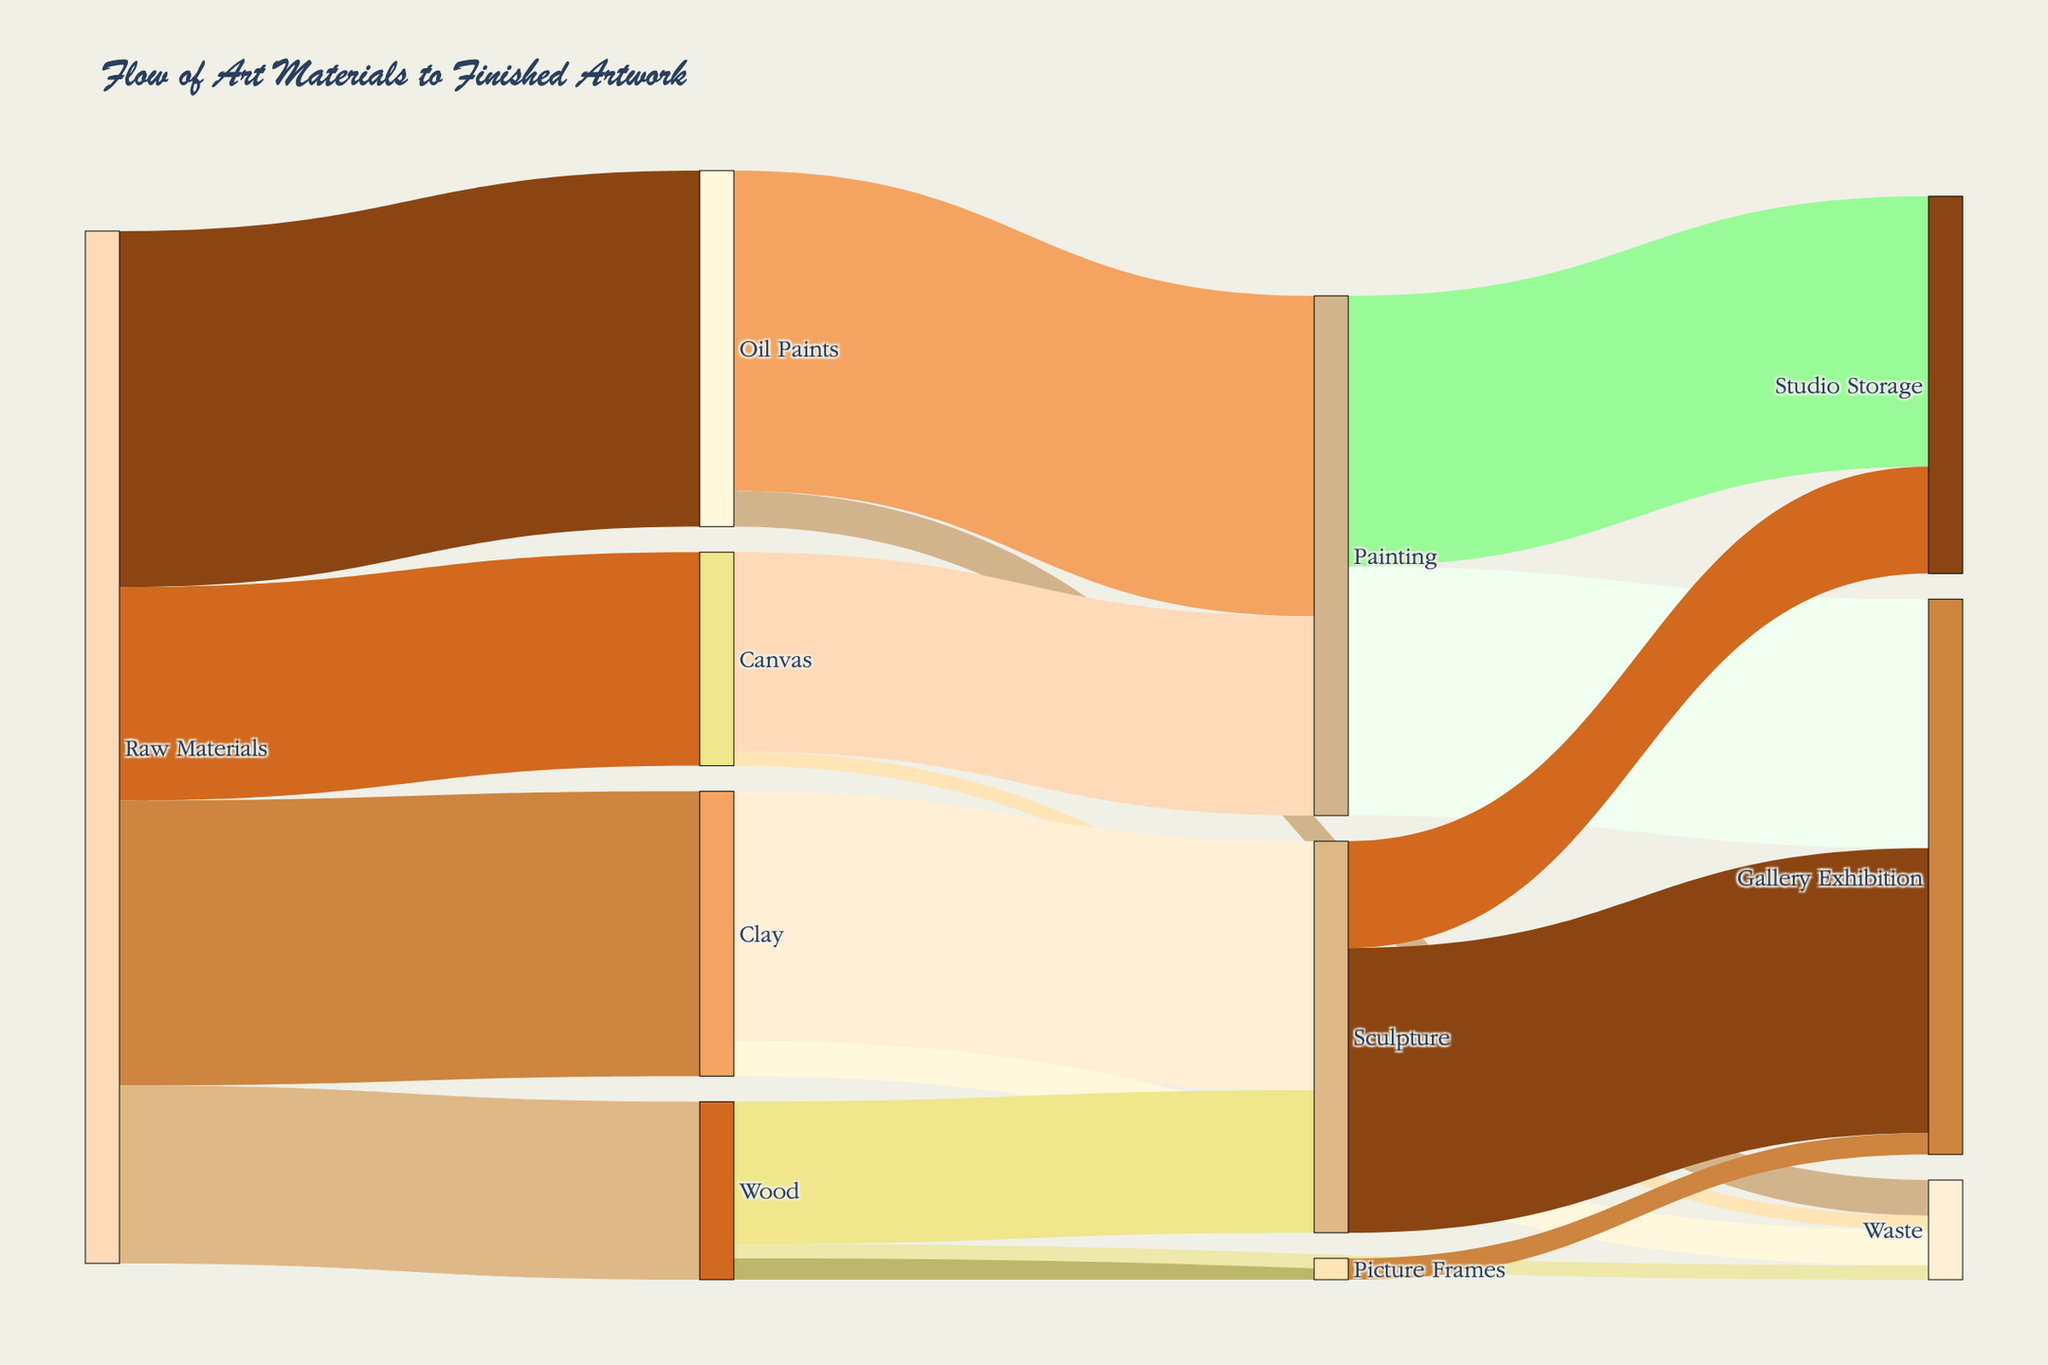What is the title of the figure? The title is located at the top of the Sankey diagram and usually provides the main context of the visualization. Here, it indicates what the diagram is about.
Answer: Flow of Art Materials to Finished Artwork How many types of raw materials are used? By counting the distinct 'source' nodes connected to 'Raw Materials', we can determine the variety of raw materials.
Answer: 4 Which raw material has the highest amount used in creating finished art pieces? By looking at the flow values from 'Raw Materials' to their respective targets, we can identify the material with the highest value.
Answer: Oil Paints (50 units) How much waste is generated from canvas? We find the 'Canvas' node and check the flow directed towards 'Waste' to know the exact amount of waste generated.
Answer: 2 units What is the total amount of material directed towards gallery exhibitions? Summing up the flow values directed to 'Gallery Exhibition' from 'Painting', 'Sculpture', and 'Picture Frames'. This involves adding 35 + 40 + 3.
Answer: 78 units Which finished art form has more waste: Painting or Sculpture? By comparing the waste flows from 'Painting' and 'Sculpture', we can see where more material is wasted.
Answer: Painting (5 units for Painting, 5 units for Sculpture) What is the difference between the amount of clay used in sculptures and the amount of wood used in sculptures? Subtract the flow value of 'Wood' to 'Sculpture' from the flow value of 'Clay' to 'Sculpture' to find the difference.
Answer: 15 units (35 - 20) How much wood is wasted? Check the flow from the 'Wood' node to the 'Waste' node to determine the total amount wasted.
Answer: 2 units How many units end up in studio storage for both painting and sculpture collectively? Add the units of 'Painting' and 'Sculpture' that flow into 'Studio Storage', i.e., 38 + 15.
Answer: 53 units Which art form has the most material going into gallery exhibitions? Compare the flow values from each art form ('Painting', 'Sculpture', 'Picture Frames') to the 'Gallery Exhibition' to see which has the highest value.
Answer: Sculpture (40 units) 